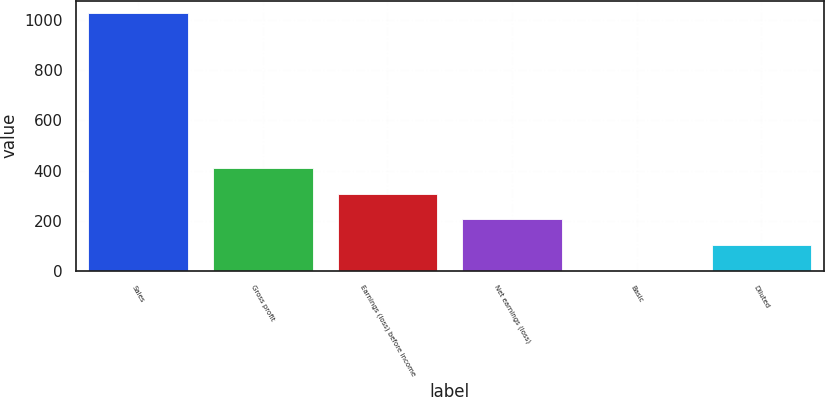<chart> <loc_0><loc_0><loc_500><loc_500><bar_chart><fcel>Sales<fcel>Gross profit<fcel>Earnings (loss) before income<fcel>Net earnings (loss)<fcel>Basic<fcel>Diluted<nl><fcel>1026.2<fcel>410.76<fcel>308.19<fcel>205.62<fcel>0.48<fcel>103.05<nl></chart> 